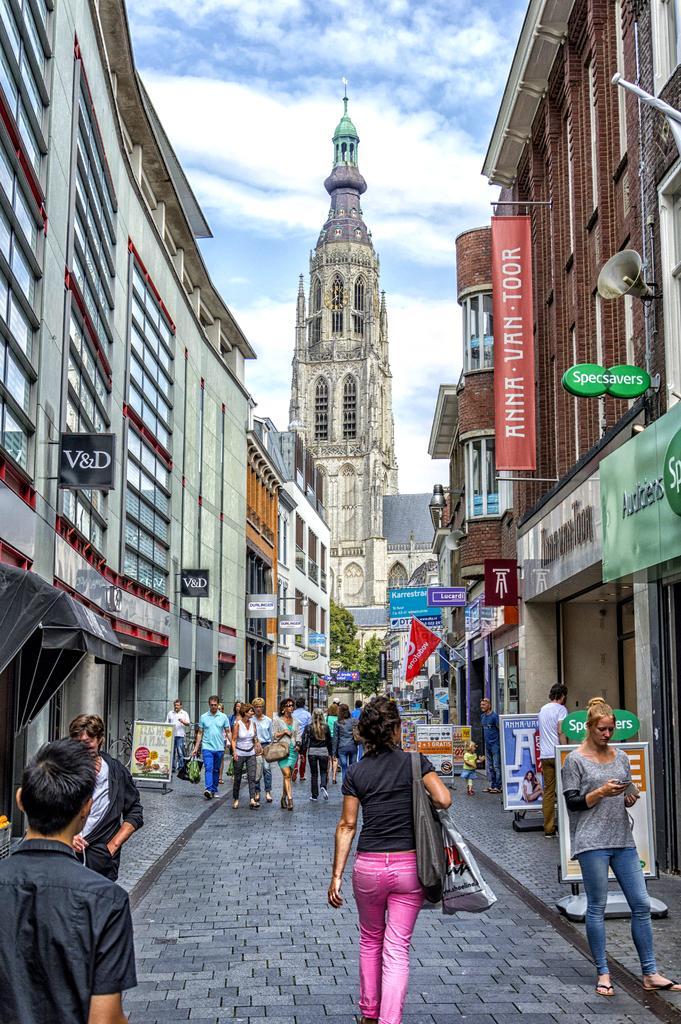Please provide a concise description of this image. In this picture we can see buildings, there are some people walking at the bottom, we can see some hoardings, a flag, trees and boards in the middle, there is the sky at the top of the picture, on the right side we can see a loudspeaker. 